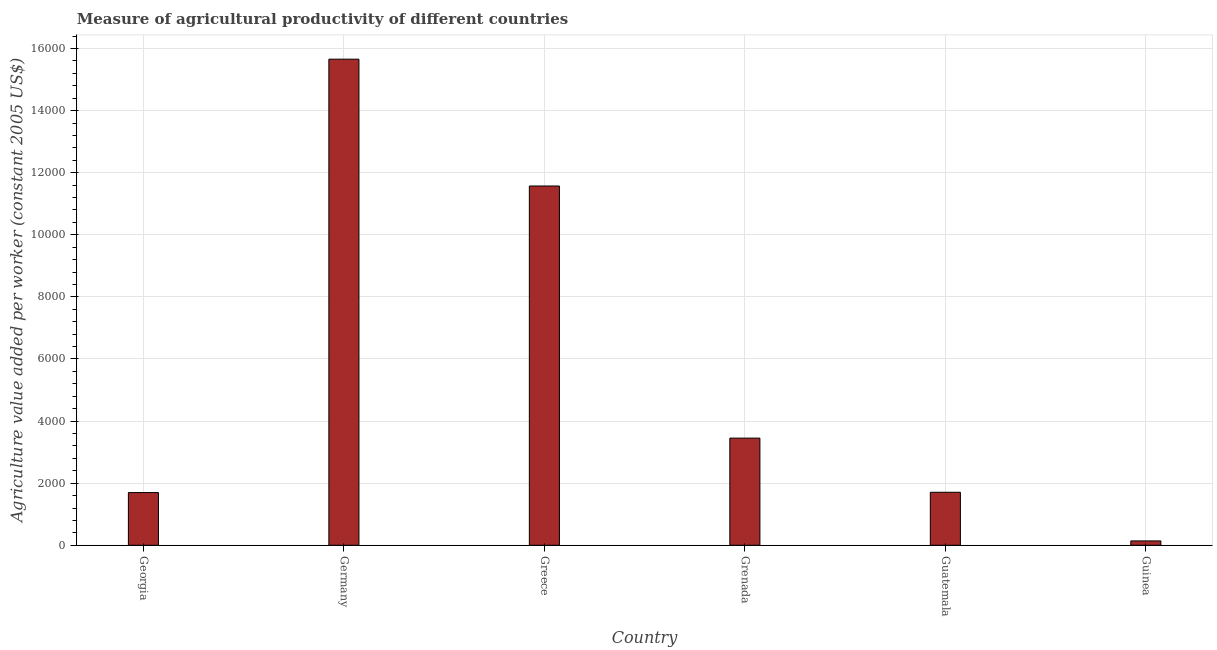Does the graph contain any zero values?
Ensure brevity in your answer.  No. What is the title of the graph?
Ensure brevity in your answer.  Measure of agricultural productivity of different countries. What is the label or title of the Y-axis?
Your response must be concise. Agriculture value added per worker (constant 2005 US$). What is the agriculture value added per worker in Greece?
Keep it short and to the point. 1.16e+04. Across all countries, what is the maximum agriculture value added per worker?
Offer a very short reply. 1.57e+04. Across all countries, what is the minimum agriculture value added per worker?
Offer a terse response. 140.28. In which country was the agriculture value added per worker maximum?
Your response must be concise. Germany. In which country was the agriculture value added per worker minimum?
Offer a terse response. Guinea. What is the sum of the agriculture value added per worker?
Your answer should be compact. 3.42e+04. What is the difference between the agriculture value added per worker in Georgia and Guatemala?
Ensure brevity in your answer.  -9.73. What is the average agriculture value added per worker per country?
Give a very brief answer. 5703.77. What is the median agriculture value added per worker?
Your response must be concise. 2579.13. What is the ratio of the agriculture value added per worker in Germany to that in Grenada?
Your response must be concise. 4.54. Is the difference between the agriculture value added per worker in Greece and Guatemala greater than the difference between any two countries?
Give a very brief answer. No. What is the difference between the highest and the second highest agriculture value added per worker?
Your answer should be very brief. 4084.4. Is the sum of the agriculture value added per worker in Georgia and Guatemala greater than the maximum agriculture value added per worker across all countries?
Offer a terse response. No. What is the difference between the highest and the lowest agriculture value added per worker?
Offer a very short reply. 1.55e+04. In how many countries, is the agriculture value added per worker greater than the average agriculture value added per worker taken over all countries?
Give a very brief answer. 2. What is the Agriculture value added per worker (constant 2005 US$) of Georgia?
Provide a succinct answer. 1697.21. What is the Agriculture value added per worker (constant 2005 US$) in Germany?
Your answer should be compact. 1.57e+04. What is the Agriculture value added per worker (constant 2005 US$) in Greece?
Keep it short and to the point. 1.16e+04. What is the Agriculture value added per worker (constant 2005 US$) of Grenada?
Offer a terse response. 3451.31. What is the Agriculture value added per worker (constant 2005 US$) in Guatemala?
Your answer should be compact. 1706.94. What is the Agriculture value added per worker (constant 2005 US$) of Guinea?
Give a very brief answer. 140.28. What is the difference between the Agriculture value added per worker (constant 2005 US$) in Georgia and Germany?
Keep it short and to the point. -1.40e+04. What is the difference between the Agriculture value added per worker (constant 2005 US$) in Georgia and Greece?
Your answer should be very brief. -9874.04. What is the difference between the Agriculture value added per worker (constant 2005 US$) in Georgia and Grenada?
Provide a succinct answer. -1754.11. What is the difference between the Agriculture value added per worker (constant 2005 US$) in Georgia and Guatemala?
Offer a terse response. -9.73. What is the difference between the Agriculture value added per worker (constant 2005 US$) in Georgia and Guinea?
Offer a very short reply. 1556.93. What is the difference between the Agriculture value added per worker (constant 2005 US$) in Germany and Greece?
Provide a short and direct response. 4084.4. What is the difference between the Agriculture value added per worker (constant 2005 US$) in Germany and Grenada?
Your answer should be very brief. 1.22e+04. What is the difference between the Agriculture value added per worker (constant 2005 US$) in Germany and Guatemala?
Keep it short and to the point. 1.39e+04. What is the difference between the Agriculture value added per worker (constant 2005 US$) in Germany and Guinea?
Your response must be concise. 1.55e+04. What is the difference between the Agriculture value added per worker (constant 2005 US$) in Greece and Grenada?
Provide a short and direct response. 8119.94. What is the difference between the Agriculture value added per worker (constant 2005 US$) in Greece and Guatemala?
Make the answer very short. 9864.31. What is the difference between the Agriculture value added per worker (constant 2005 US$) in Greece and Guinea?
Your response must be concise. 1.14e+04. What is the difference between the Agriculture value added per worker (constant 2005 US$) in Grenada and Guatemala?
Give a very brief answer. 1744.37. What is the difference between the Agriculture value added per worker (constant 2005 US$) in Grenada and Guinea?
Your answer should be compact. 3311.03. What is the difference between the Agriculture value added per worker (constant 2005 US$) in Guatemala and Guinea?
Ensure brevity in your answer.  1566.66. What is the ratio of the Agriculture value added per worker (constant 2005 US$) in Georgia to that in Germany?
Offer a terse response. 0.11. What is the ratio of the Agriculture value added per worker (constant 2005 US$) in Georgia to that in Greece?
Provide a short and direct response. 0.15. What is the ratio of the Agriculture value added per worker (constant 2005 US$) in Georgia to that in Grenada?
Offer a terse response. 0.49. What is the ratio of the Agriculture value added per worker (constant 2005 US$) in Georgia to that in Guinea?
Keep it short and to the point. 12.1. What is the ratio of the Agriculture value added per worker (constant 2005 US$) in Germany to that in Greece?
Provide a succinct answer. 1.35. What is the ratio of the Agriculture value added per worker (constant 2005 US$) in Germany to that in Grenada?
Keep it short and to the point. 4.54. What is the ratio of the Agriculture value added per worker (constant 2005 US$) in Germany to that in Guatemala?
Your response must be concise. 9.17. What is the ratio of the Agriculture value added per worker (constant 2005 US$) in Germany to that in Guinea?
Offer a terse response. 111.6. What is the ratio of the Agriculture value added per worker (constant 2005 US$) in Greece to that in Grenada?
Ensure brevity in your answer.  3.35. What is the ratio of the Agriculture value added per worker (constant 2005 US$) in Greece to that in Guatemala?
Offer a terse response. 6.78. What is the ratio of the Agriculture value added per worker (constant 2005 US$) in Greece to that in Guinea?
Provide a succinct answer. 82.48. What is the ratio of the Agriculture value added per worker (constant 2005 US$) in Grenada to that in Guatemala?
Provide a short and direct response. 2.02. What is the ratio of the Agriculture value added per worker (constant 2005 US$) in Grenada to that in Guinea?
Give a very brief answer. 24.6. What is the ratio of the Agriculture value added per worker (constant 2005 US$) in Guatemala to that in Guinea?
Offer a very short reply. 12.17. 